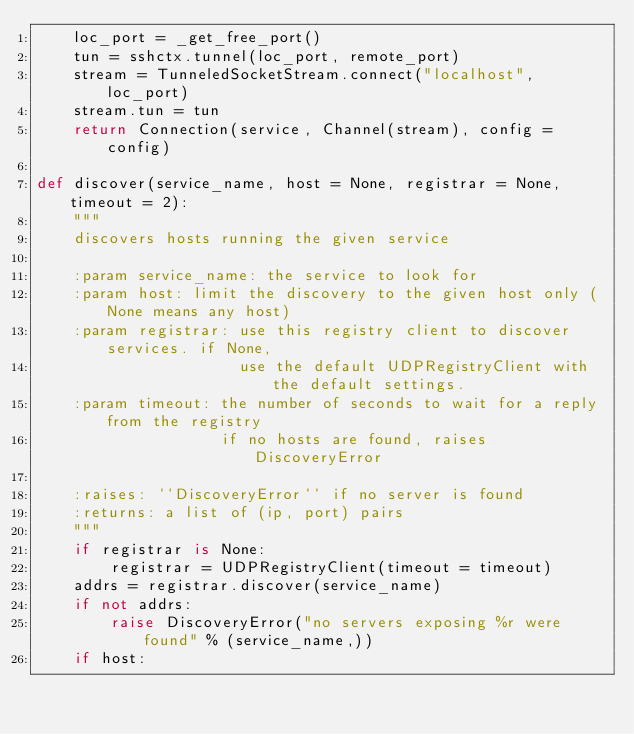Convert code to text. <code><loc_0><loc_0><loc_500><loc_500><_Python_>    loc_port = _get_free_port()
    tun = sshctx.tunnel(loc_port, remote_port)
    stream = TunneledSocketStream.connect("localhost", loc_port)
    stream.tun = tun
    return Connection(service, Channel(stream), config = config)

def discover(service_name, host = None, registrar = None, timeout = 2):
    """
    discovers hosts running the given service
    
    :param service_name: the service to look for
    :param host: limit the discovery to the given host only (None means any host)
    :param registrar: use this registry client to discover services. if None,
                      use the default UDPRegistryClient with the default settings.
    :param timeout: the number of seconds to wait for a reply from the registry
                    if no hosts are found, raises DiscoveryError
    
    :raises: ``DiscoveryError`` if no server is found
    :returns: a list of (ip, port) pairs
    """
    if registrar is None:
        registrar = UDPRegistryClient(timeout = timeout)
    addrs = registrar.discover(service_name)
    if not addrs:
        raise DiscoveryError("no servers exposing %r were found" % (service_name,))
    if host:</code> 